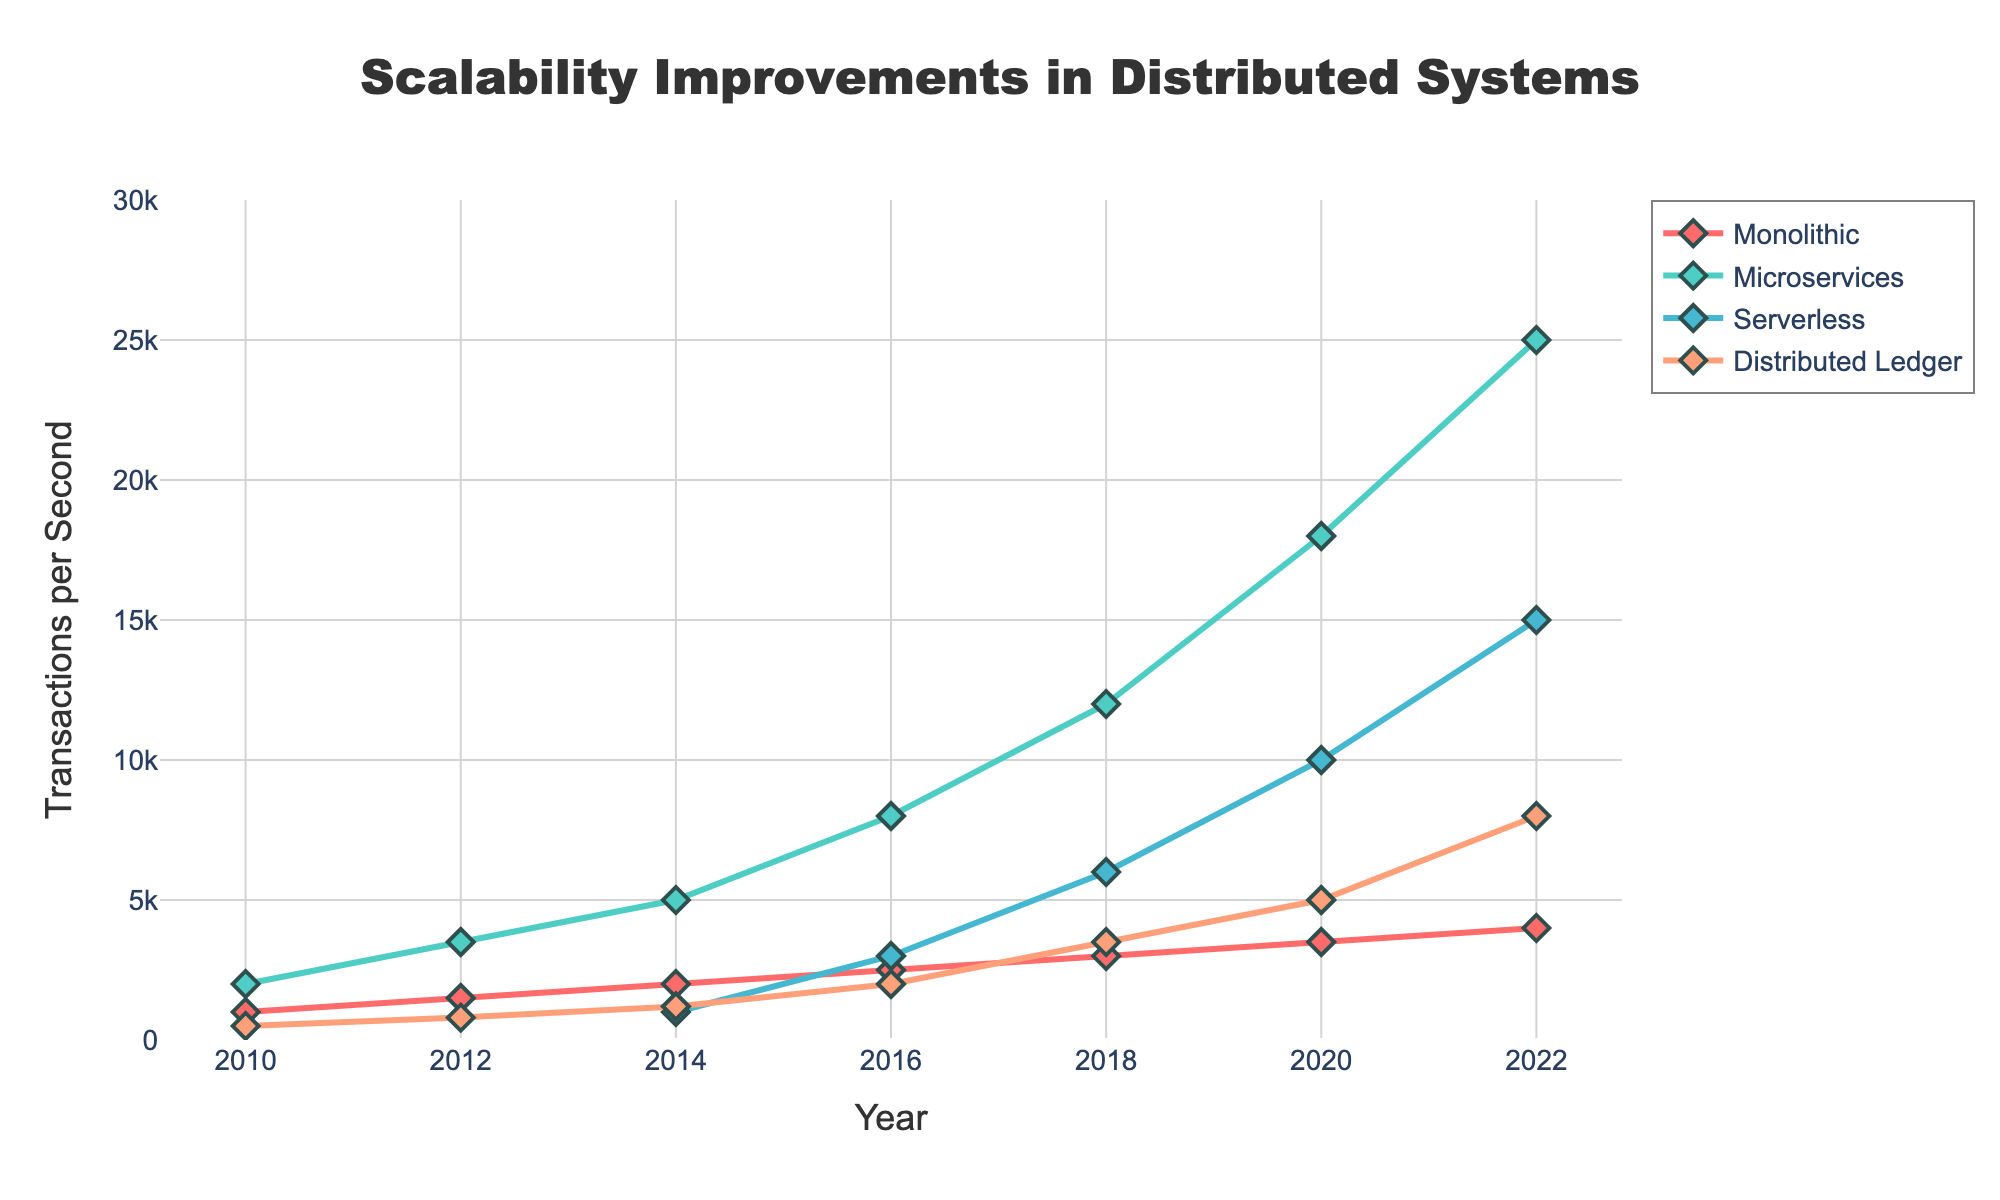Which architecture showed the greatest increase in transactions per second from 2010 to 2022? By subtracting the transactions per second in 2010 from those in 2022 for each architecture, the increases are: Monolithic (4000-1000=3000), Microservices (25000-2000=23000), Serverless (15000-0=15000), Distributed Ledger (8000-500=7500). Microservices had the greatest increase.
Answer: Microservices What year did the Serverless architecture first appear in the chart? Observing the data points for Serverless, we see it started being tracked in 2014.
Answer: 2014 Which architecture had the highest transactions per second in 2018? By checking the transactions per second for each architecture in 2018: Monolithic (3000), Microservices (12000), Serverless (6000), Distributed Ledger (3500). Microservices had the highest value.
Answer: Microservices Between which years did the Microservices architecture see the largest single increase in transactions per second? Comparing the increase between years for Microservices: 2010-2012 (3500-2000=1500), 2012-2014 (5000-3500=1500), 2014-2016 (8000-5000=3000), 2016-2018 (12000-8000=4000), 2018-2020 (18000-12000=6000), 2020-2022 (25000-18000=7000). The largest increase was between 2020 and 2022.
Answer: 2020-2022 By how much did the transactions per second for the Distributed Ledger architecture increase from 2012 to 2018? Comparing the transactions per second values for Distributed Ledger in 2012 and 2018: 2018 (3500) - 2012 (800) = 2700.
Answer: 2700 How many architectures exceeded 5000 transactions per second in 2020? Checking the transactions per second values for each architecture in 2020: Monolithic (3500), Microservices (18000), Serverless (10000), Distributed Ledger (5000). Only Microservices and Serverless exceeded 5000.
Answer: 2 What is the total number of transactions per second handled by all architectures combined in 2016? Adding up the transactions per second for all architectures in 2016: Monolithic (2500) + Microservices (8000) + Serverless (3000) + Distributed Ledger (2000) = 15500.
Answer: 15500 What is the average transactions per second handled by the Microservices architecture in 2014, 2016, and 2018? Adding the transactions per second for these years: 2014 (5000) + 2016 (8000) + 2018 (12000) = 25000. The average is 25000 / 3 = 8333.33.
Answer: 8333.33 Which architecture had the lowest transactions per second in 2010? Checking the transactions per second values for each architecture in 2010: Monolithic (1000), Microservices (2000), Serverless (N/A), Distributed Ledger (500). The lowest is Distributed Ledger.
Answer: Distributed Ledger 